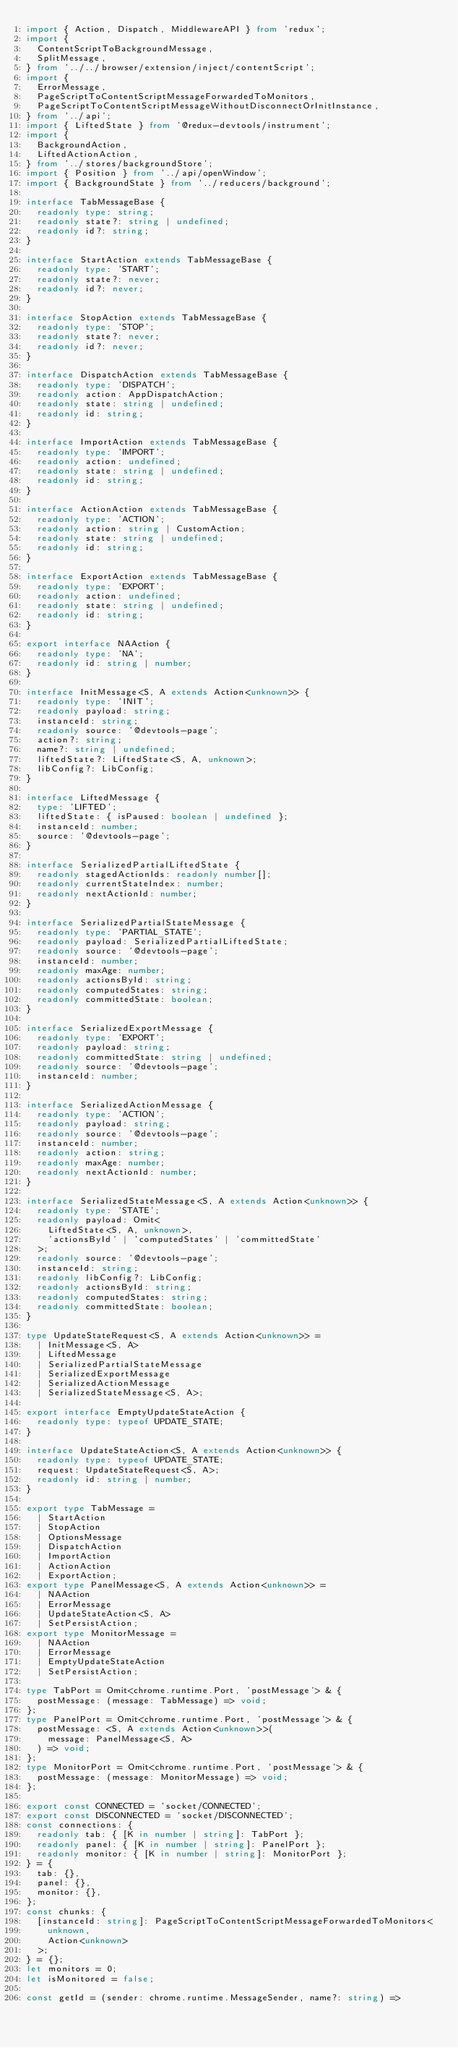<code> <loc_0><loc_0><loc_500><loc_500><_TypeScript_>import { Action, Dispatch, MiddlewareAPI } from 'redux';
import {
  ContentScriptToBackgroundMessage,
  SplitMessage,
} from '../../browser/extension/inject/contentScript';
import {
  ErrorMessage,
  PageScriptToContentScriptMessageForwardedToMonitors,
  PageScriptToContentScriptMessageWithoutDisconnectOrInitInstance,
} from '../api';
import { LiftedState } from '@redux-devtools/instrument';
import {
  BackgroundAction,
  LiftedActionAction,
} from '../stores/backgroundStore';
import { Position } from '../api/openWindow';
import { BackgroundState } from '../reducers/background';

interface TabMessageBase {
  readonly type: string;
  readonly state?: string | undefined;
  readonly id?: string;
}

interface StartAction extends TabMessageBase {
  readonly type: 'START';
  readonly state?: never;
  readonly id?: never;
}

interface StopAction extends TabMessageBase {
  readonly type: 'STOP';
  readonly state?: never;
  readonly id?: never;
}

interface DispatchAction extends TabMessageBase {
  readonly type: 'DISPATCH';
  readonly action: AppDispatchAction;
  readonly state: string | undefined;
  readonly id: string;
}

interface ImportAction extends TabMessageBase {
  readonly type: 'IMPORT';
  readonly action: undefined;
  readonly state: string | undefined;
  readonly id: string;
}

interface ActionAction extends TabMessageBase {
  readonly type: 'ACTION';
  readonly action: string | CustomAction;
  readonly state: string | undefined;
  readonly id: string;
}

interface ExportAction extends TabMessageBase {
  readonly type: 'EXPORT';
  readonly action: undefined;
  readonly state: string | undefined;
  readonly id: string;
}

export interface NAAction {
  readonly type: 'NA';
  readonly id: string | number;
}

interface InitMessage<S, A extends Action<unknown>> {
  readonly type: 'INIT';
  readonly payload: string;
  instanceId: string;
  readonly source: '@devtools-page';
  action?: string;
  name?: string | undefined;
  liftedState?: LiftedState<S, A, unknown>;
  libConfig?: LibConfig;
}

interface LiftedMessage {
  type: 'LIFTED';
  liftedState: { isPaused: boolean | undefined };
  instanceId: number;
  source: '@devtools-page';
}

interface SerializedPartialLiftedState {
  readonly stagedActionIds: readonly number[];
  readonly currentStateIndex: number;
  readonly nextActionId: number;
}

interface SerializedPartialStateMessage {
  readonly type: 'PARTIAL_STATE';
  readonly payload: SerializedPartialLiftedState;
  readonly source: '@devtools-page';
  instanceId: number;
  readonly maxAge: number;
  readonly actionsById: string;
  readonly computedStates: string;
  readonly committedState: boolean;
}

interface SerializedExportMessage {
  readonly type: 'EXPORT';
  readonly payload: string;
  readonly committedState: string | undefined;
  readonly source: '@devtools-page';
  instanceId: number;
}

interface SerializedActionMessage {
  readonly type: 'ACTION';
  readonly payload: string;
  readonly source: '@devtools-page';
  instanceId: number;
  readonly action: string;
  readonly maxAge: number;
  readonly nextActionId: number;
}

interface SerializedStateMessage<S, A extends Action<unknown>> {
  readonly type: 'STATE';
  readonly payload: Omit<
    LiftedState<S, A, unknown>,
    'actionsById' | 'computedStates' | 'committedState'
  >;
  readonly source: '@devtools-page';
  instanceId: string;
  readonly libConfig?: LibConfig;
  readonly actionsById: string;
  readonly computedStates: string;
  readonly committedState: boolean;
}

type UpdateStateRequest<S, A extends Action<unknown>> =
  | InitMessage<S, A>
  | LiftedMessage
  | SerializedPartialStateMessage
  | SerializedExportMessage
  | SerializedActionMessage
  | SerializedStateMessage<S, A>;

export interface EmptyUpdateStateAction {
  readonly type: typeof UPDATE_STATE;
}

interface UpdateStateAction<S, A extends Action<unknown>> {
  readonly type: typeof UPDATE_STATE;
  request: UpdateStateRequest<S, A>;
  readonly id: string | number;
}

export type TabMessage =
  | StartAction
  | StopAction
  | OptionsMessage
  | DispatchAction
  | ImportAction
  | ActionAction
  | ExportAction;
export type PanelMessage<S, A extends Action<unknown>> =
  | NAAction
  | ErrorMessage
  | UpdateStateAction<S, A>
  | SetPersistAction;
export type MonitorMessage =
  | NAAction
  | ErrorMessage
  | EmptyUpdateStateAction
  | SetPersistAction;

type TabPort = Omit<chrome.runtime.Port, 'postMessage'> & {
  postMessage: (message: TabMessage) => void;
};
type PanelPort = Omit<chrome.runtime.Port, 'postMessage'> & {
  postMessage: <S, A extends Action<unknown>>(
    message: PanelMessage<S, A>
  ) => void;
};
type MonitorPort = Omit<chrome.runtime.Port, 'postMessage'> & {
  postMessage: (message: MonitorMessage) => void;
};

export const CONNECTED = 'socket/CONNECTED';
export const DISCONNECTED = 'socket/DISCONNECTED';
const connections: {
  readonly tab: { [K in number | string]: TabPort };
  readonly panel: { [K in number | string]: PanelPort };
  readonly monitor: { [K in number | string]: MonitorPort };
} = {
  tab: {},
  panel: {},
  monitor: {},
};
const chunks: {
  [instanceId: string]: PageScriptToContentScriptMessageForwardedToMonitors<
    unknown,
    Action<unknown>
  >;
} = {};
let monitors = 0;
let isMonitored = false;

const getId = (sender: chrome.runtime.MessageSender, name?: string) =></code> 